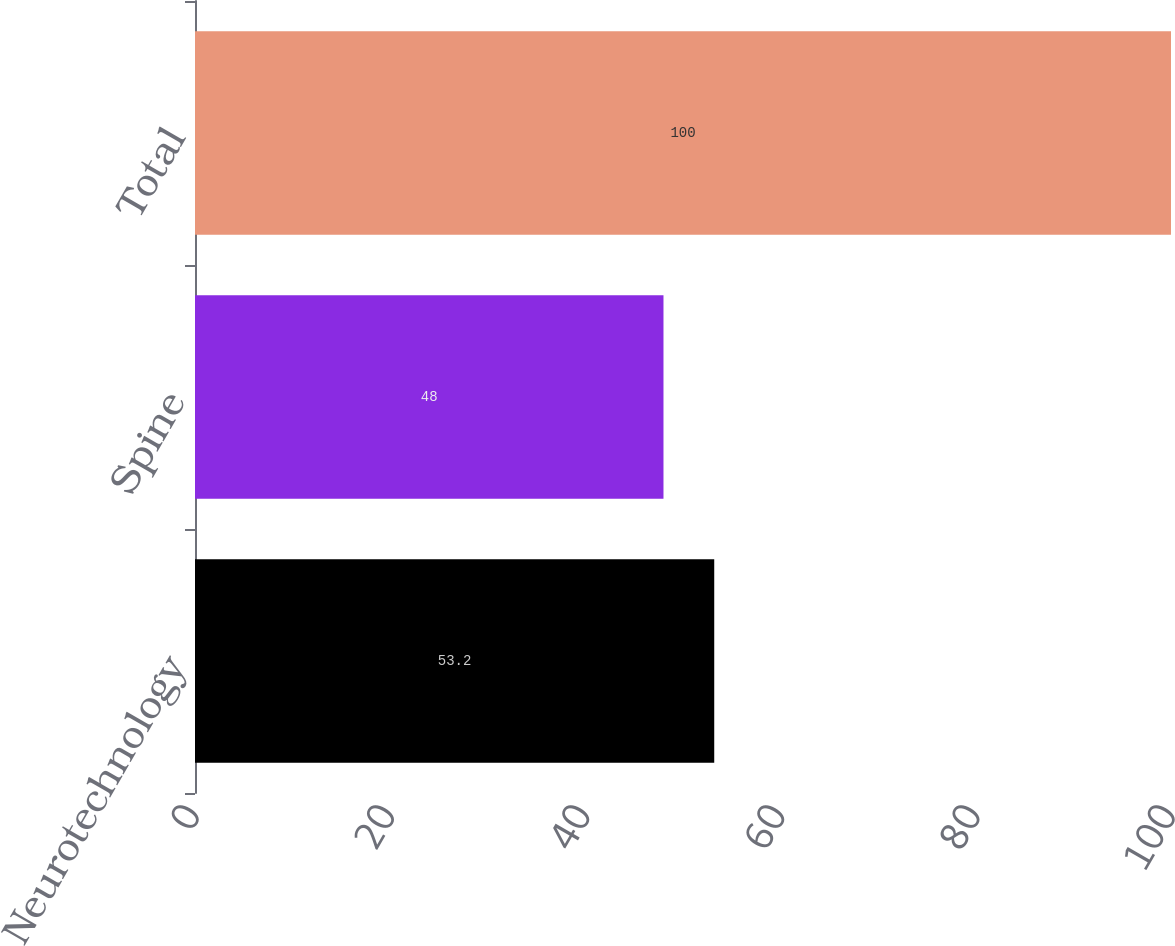<chart> <loc_0><loc_0><loc_500><loc_500><bar_chart><fcel>Neurotechnology<fcel>Spine<fcel>Total<nl><fcel>53.2<fcel>48<fcel>100<nl></chart> 